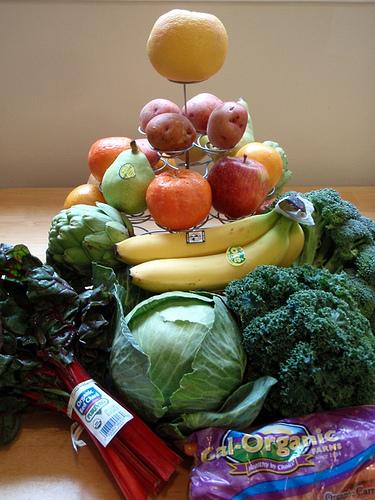Is there cabbage in the picture?
Be succinct. Yes. What vegetable is on top of the rack?
Answer briefly. Orange. How many potatoes are there?
Keep it brief. 4. Where is this displayed?
Quick response, please. Table. 